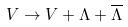Convert formula to latex. <formula><loc_0><loc_0><loc_500><loc_500>V \rightarrow V + \Lambda + \overline { \Lambda }</formula> 